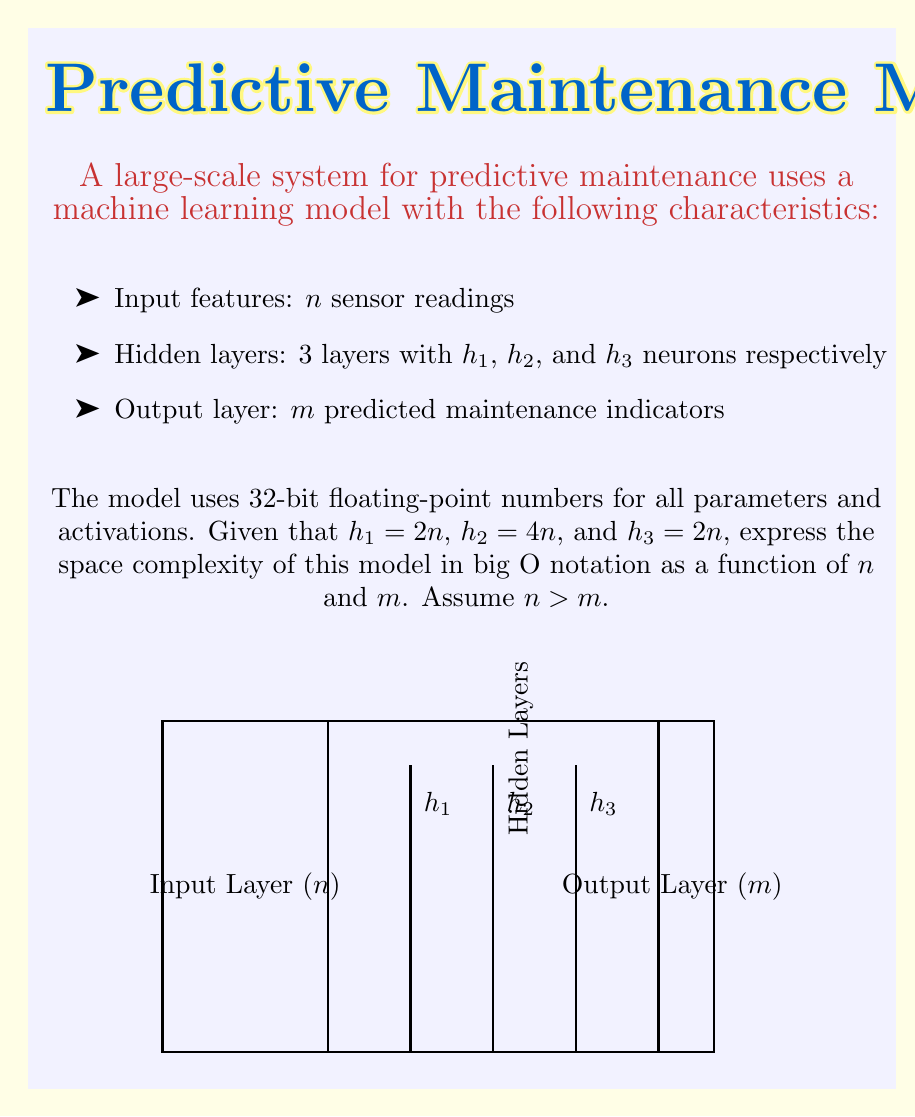Provide a solution to this math problem. To determine the space complexity, we need to count the number of parameters in the model:

1. Input to first hidden layer:
   - Weight matrix: $n \times h_1 = n \times 2n = 2n^2$
   - Bias vector: $h_1 = 2n$
   - Total: $2n^2 + 2n$

2. First to second hidden layer:
   - Weight matrix: $h_1 \times h_2 = 2n \times 4n = 8n^2$
   - Bias vector: $h_2 = 4n$
   - Total: $8n^2 + 4n$

3. Second to third hidden layer:
   - Weight matrix: $h_2 \times h_3 = 4n \times 2n = 8n^2$
   - Bias vector: $h_3 = 2n$
   - Total: $8n^2 + 2n$

4. Third hidden layer to output:
   - Weight matrix: $h_3 \times m = 2n \times m = 2nm$
   - Bias vector: $m$
   - Total: $2nm + m$

Sum of all parameters:
$$(2n^2 + 2n) + (8n^2 + 4n) + (8n^2 + 2n) + (2nm + m)$$
$$= 18n^2 + 8n + 2nm + m$$

Each parameter uses 32 bits (4 bytes), so the total space in bytes is:
$$4(18n^2 + 8n + 2nm + m)$$

The dominant terms are $n^2$ and $nm$. Since $n > m$, $n^2$ grows faster than $nm$.

In big O notation, we ignore constants and lower-order terms, resulting in $O(n^2)$.
Answer: $O(n^2)$ 